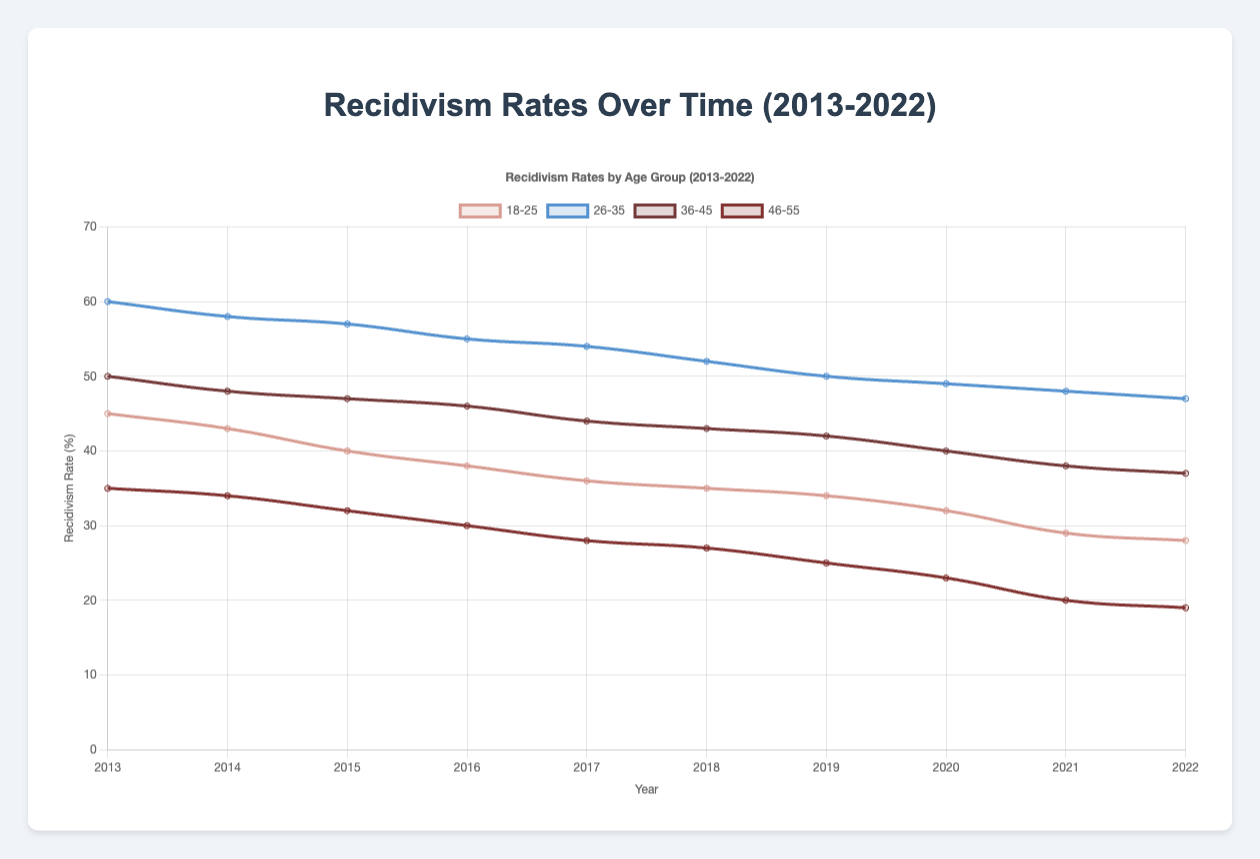What is the trend of recidivism rates for the age group 18-25 in drug-related offenses from 2013 to 2022? The recidivism rates for the age group 18-25 in drug-related offenses have been steadily decreasing from 45% in 2013 to 28% in 2022.
Answer: Decreasing Which age group experienced the highest recidivism rate in 2013? In 2013, the age group 26-35 for violent offenses had the highest recidivism rate at 60%.
Answer: 26-35 Comparing 2018 and 2022, which year had lower recidivism rates for the age group 46-55 in drug-related offenses? In 2018, the recidivism rate for the age group 46-55 in drug-related offenses was 27%. In 2022, it was 19%. 2022 had the lower recidivism rate.
Answer: 2022 What is the difference in recidivism rates between the age groups 36-45 and 18-25 for the year 2020? In 2020, the recidivism rate for the age group 36-45 was 40% and for the age group 18-25, it was 32%. The difference is 40% - 32% = 8%.
Answer: 8% Which age group shows the most significant decline in recidivism rate from 2013 to 2022? The age group 46-55 shows a decline from 35% in 2013 to 19% in 2022, which is a difference of 16%.
Answer: 46-55 How do the recidivism rates for the age group 26-35 in violent offenses compare between 2013 and 2022? In 2013, the recidivism rate for the age group 26-35 in violent offenses was 60%. In 2022, it was 47%. The rate decreased by 13%.
Answer: Decreased by 13% Which rehabilitation program had the highest recidivism rate in 2015? In 2015, the Behavioral Therapy program for the age group 26-35 and violent offenses had the highest recidivism rate at 57%.
Answer: Behavioral Therapy for 26-35 Violent What is the average recidivism rate for the age group 18-25 in drug-related offenses over the decade? Summing the rates (45, 43, 40, 38, 36, 35, 34, 32, 29, 28) for each year from 2013 to 2022, the total is 360. There are 10 data points, so the average rate is 360/10 = 36%.
Answer: 36% How did the recidivism rate for the age group 36-45 in property crime change from 2015 to 2018? In 2015, the rate was 47%. In 2018, it was 43%. The rate decreased by 47% - 43% = 4%.
Answer: Decreased by 4% Which age group had the lowest recidivism rate in 2022, and what was the rate? In 2022, the age group 46-55 in drug-related offenses had the lowest recidivism rate at 19%.
Answer: 46-55, 19% 